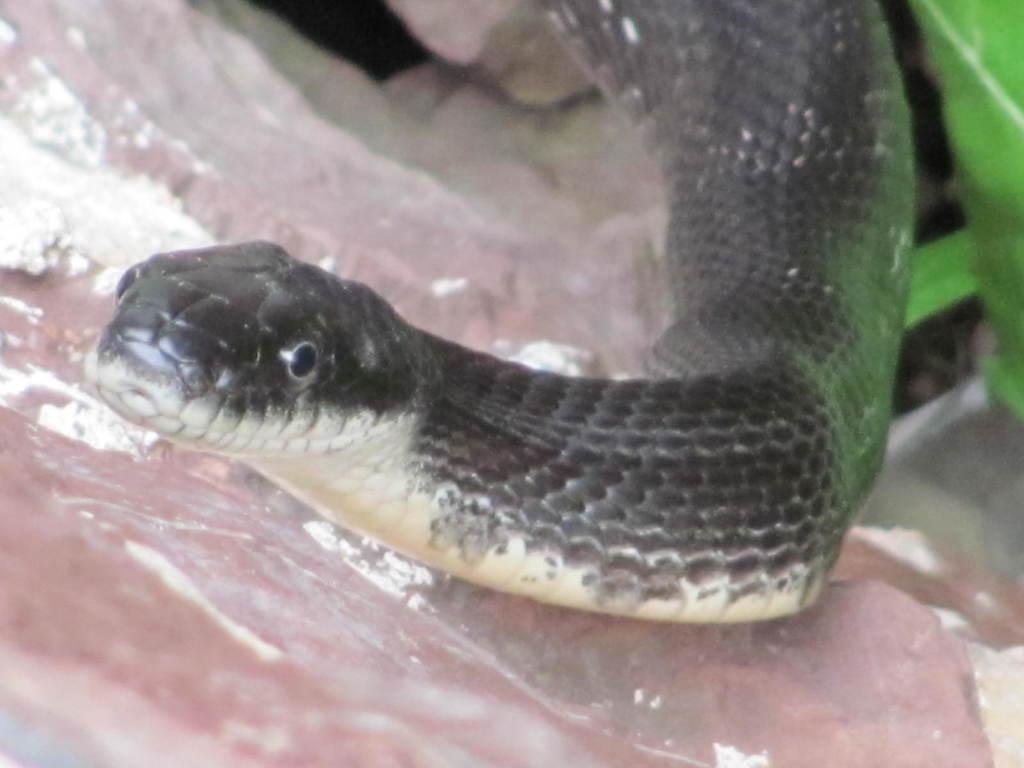In one or two sentences, can you explain what this image depicts? In this picture we can see a black snake and in the background we can see a rock. 